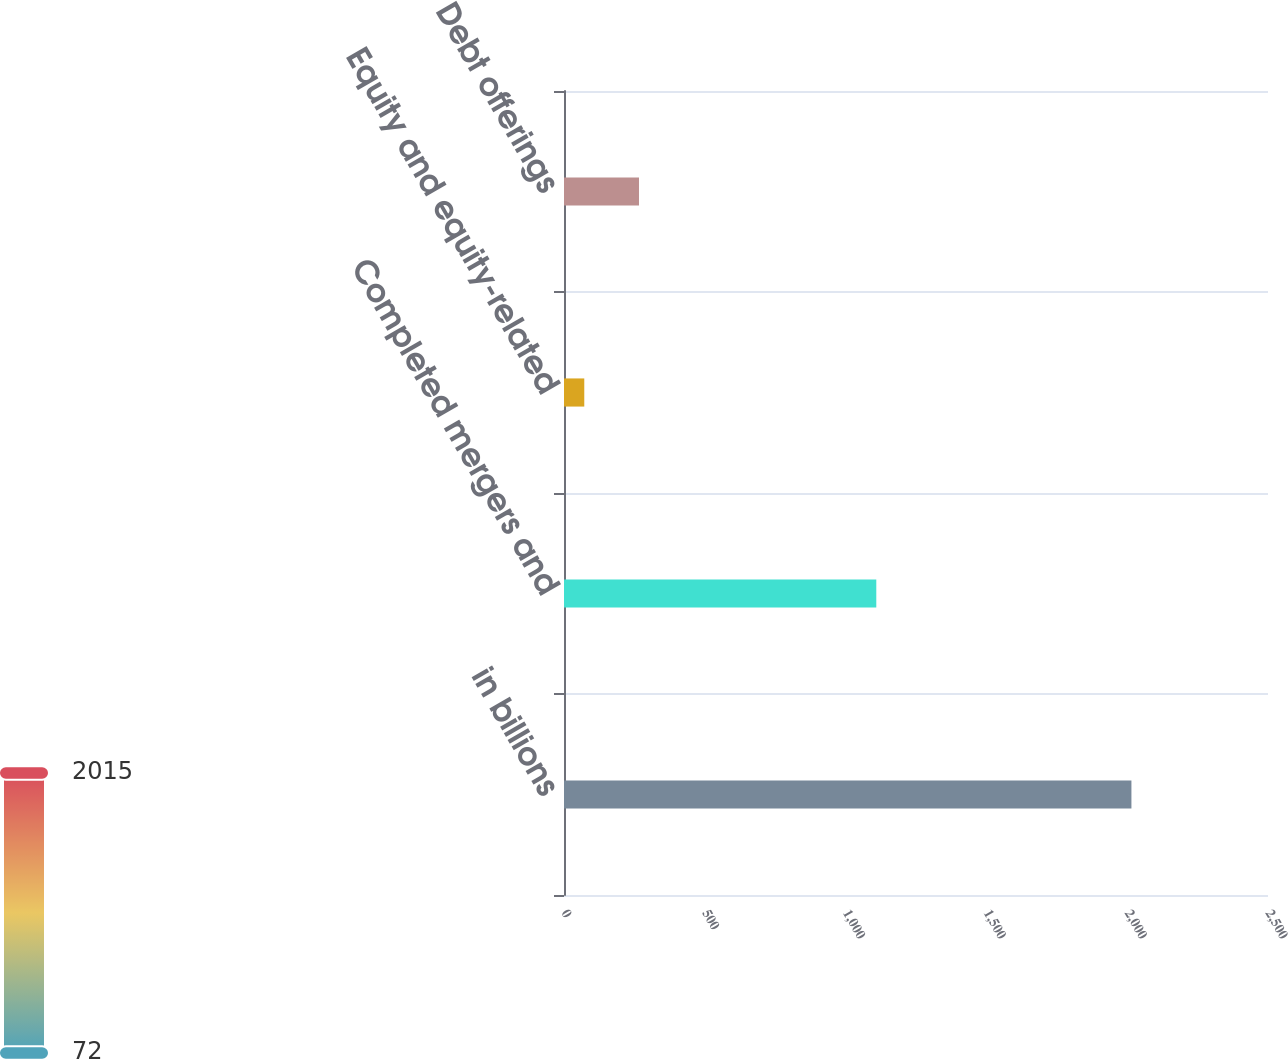Convert chart. <chart><loc_0><loc_0><loc_500><loc_500><bar_chart><fcel>in billions<fcel>Completed mergers and<fcel>Equity and equity-related<fcel>Debt offerings<nl><fcel>2015<fcel>1109<fcel>72<fcel>266.3<nl></chart> 